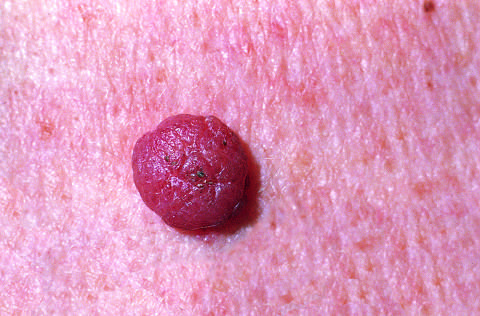re melanocytic nevi relatively small, symmetric, and uniformly pigmented?
Answer the question using a single word or phrase. Yes 